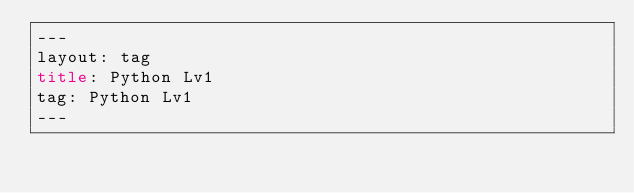Convert code to text. <code><loc_0><loc_0><loc_500><loc_500><_HTML_>---
layout: tag
title: Python Lv1
tag: Python Lv1
---
</code> 